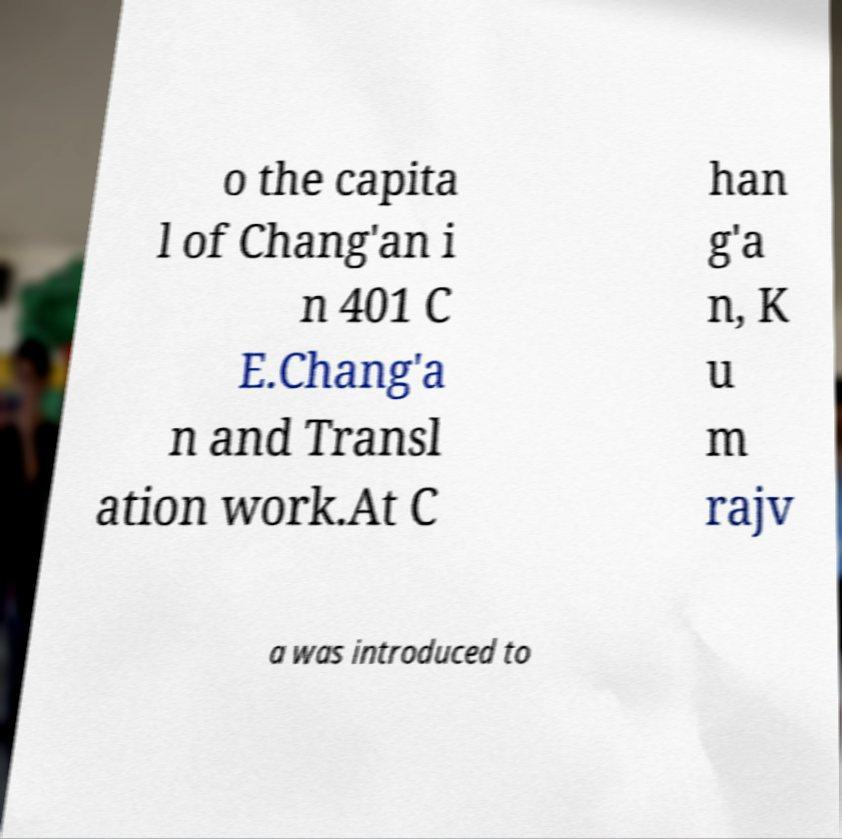Could you assist in decoding the text presented in this image and type it out clearly? o the capita l of Chang'an i n 401 C E.Chang'a n and Transl ation work.At C han g'a n, K u m rajv a was introduced to 